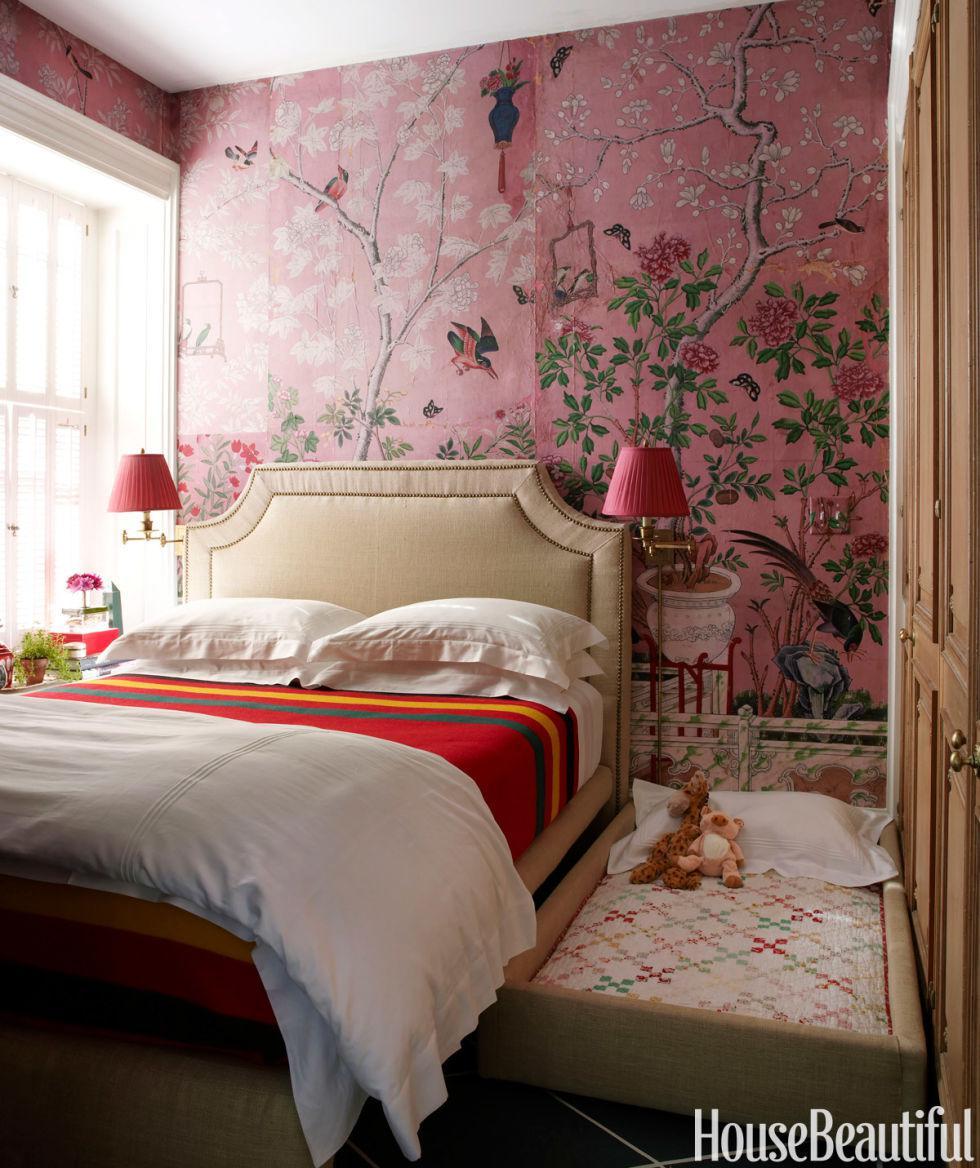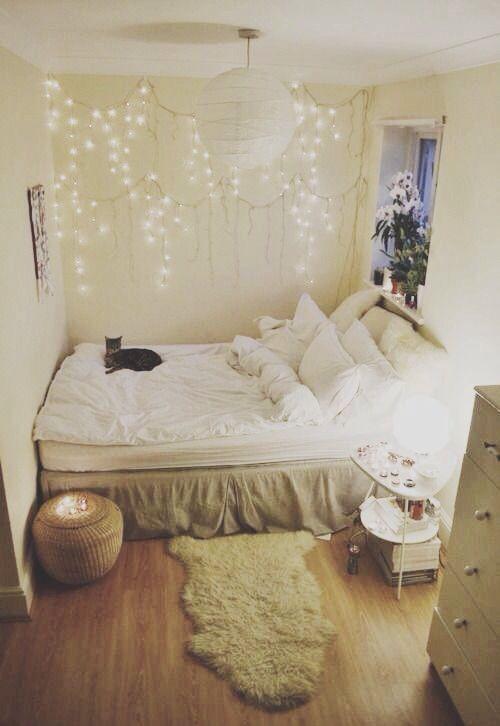The first image is the image on the left, the second image is the image on the right. For the images shown, is this caption "The left image includes a white corner shelf." true? Answer yes or no. No. 